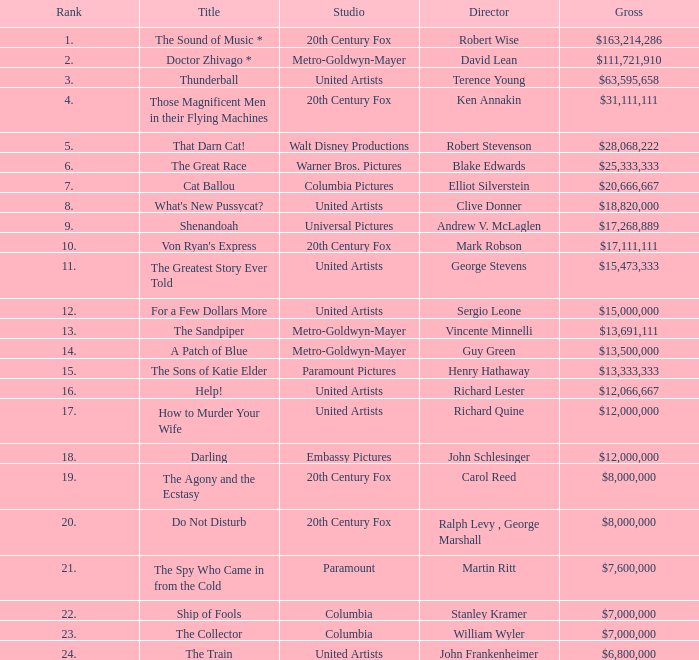What is the studio, when the name is "do not disturb"? 20th Century Fox. 